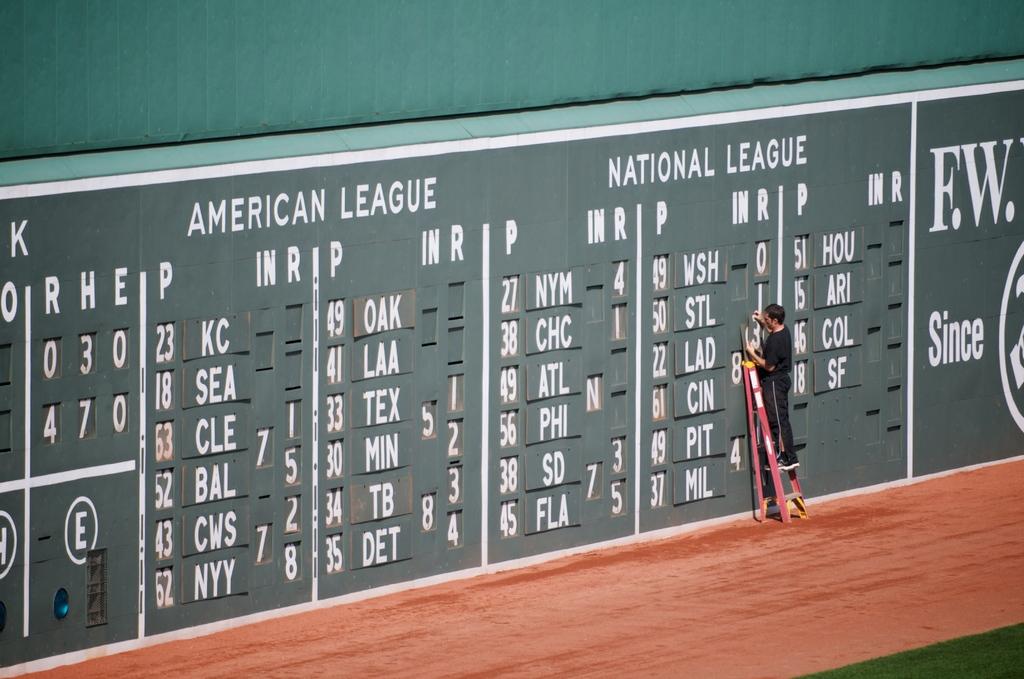Who is at the top of the national league board?
Offer a very short reply. Wsh. What two leagues are these?
Provide a short and direct response. American and national. 